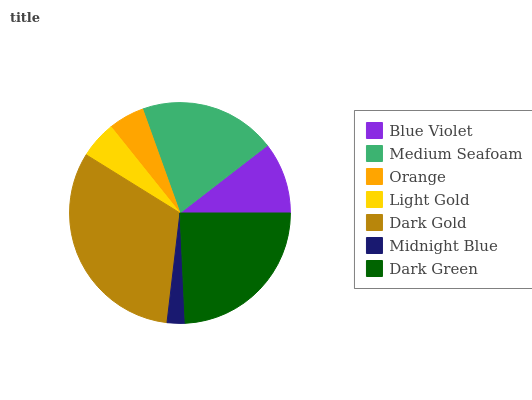Is Midnight Blue the minimum?
Answer yes or no. Yes. Is Dark Gold the maximum?
Answer yes or no. Yes. Is Medium Seafoam the minimum?
Answer yes or no. No. Is Medium Seafoam the maximum?
Answer yes or no. No. Is Medium Seafoam greater than Blue Violet?
Answer yes or no. Yes. Is Blue Violet less than Medium Seafoam?
Answer yes or no. Yes. Is Blue Violet greater than Medium Seafoam?
Answer yes or no. No. Is Medium Seafoam less than Blue Violet?
Answer yes or no. No. Is Blue Violet the high median?
Answer yes or no. Yes. Is Blue Violet the low median?
Answer yes or no. Yes. Is Orange the high median?
Answer yes or no. No. Is Dark Gold the low median?
Answer yes or no. No. 